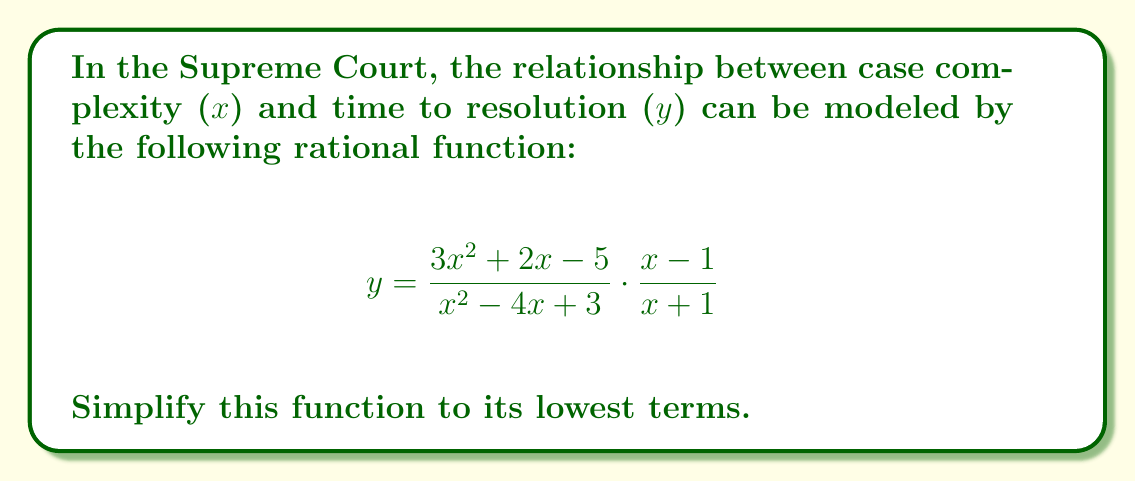Help me with this question. Let's simplify this rational function step by step:

1) First, let's multiply the numerators and denominators:

   $$y = \frac{(3x^2 + 2x - 5)(x - 1)}{(x^2 - 4x + 3)(x + 1)}$$

2) Expand the numerator:
   $(3x^2 + 2x - 5)(x - 1) = 3x^3 - 3x^2 + 2x^2 - 2x - 5x + 5$
                            $= 3x^3 - x^2 - 7x + 5$

3) Expand the denominator:
   $(x^2 - 4x + 3)(x + 1) = x^3 + x^2 - 4x^2 - 4x + 3x + 3$
                           $= x^3 - 3x^2 - x + 3$

4) Now our function looks like:

   $$y = \frac{3x^3 - x^2 - 7x + 5}{x^3 - 3x^2 - x + 3}$$

5) We can factor out the greatest common factor in both numerator and denominator:

   Numerator: $3x^3 - x^2 - 7x + 5 = (x - 1)(3x^2 + 2x - 5)$
   Denominator: $x^3 - 3x^2 - x + 3 = (x - 1)(x^2 - 2x - 3)$

6) After canceling the common factor $(x - 1)$, we get:

   $$y = \frac{3x^2 + 2x - 5}{x^2 - 2x - 3}$$

This is the simplified form of the rational function.
Answer: $$y = \frac{3x^2 + 2x - 5}{x^2 - 2x - 3}$$ 